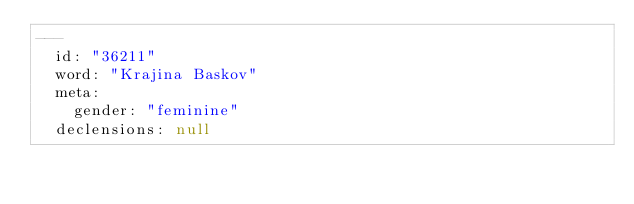Convert code to text. <code><loc_0><loc_0><loc_500><loc_500><_YAML_>---
  id: "36211"
  word: "Krajina Baskov"
  meta: 
    gender: "feminine"
  declensions: null
</code> 